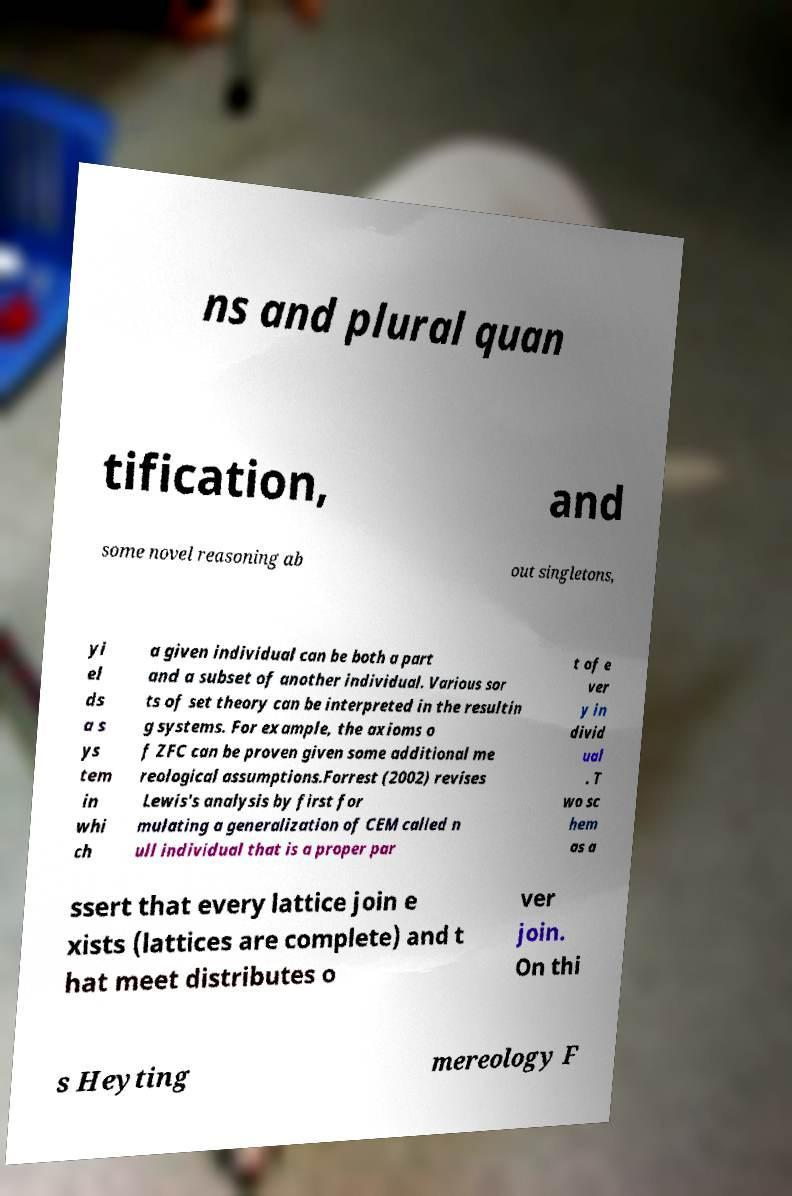Can you accurately transcribe the text from the provided image for me? ns and plural quan tification, and some novel reasoning ab out singletons, yi el ds a s ys tem in whi ch a given individual can be both a part and a subset of another individual. Various sor ts of set theory can be interpreted in the resultin g systems. For example, the axioms o f ZFC can be proven given some additional me reological assumptions.Forrest (2002) revises Lewis's analysis by first for mulating a generalization of CEM called n ull individual that is a proper par t of e ver y in divid ual . T wo sc hem as a ssert that every lattice join e xists (lattices are complete) and t hat meet distributes o ver join. On thi s Heyting mereology F 